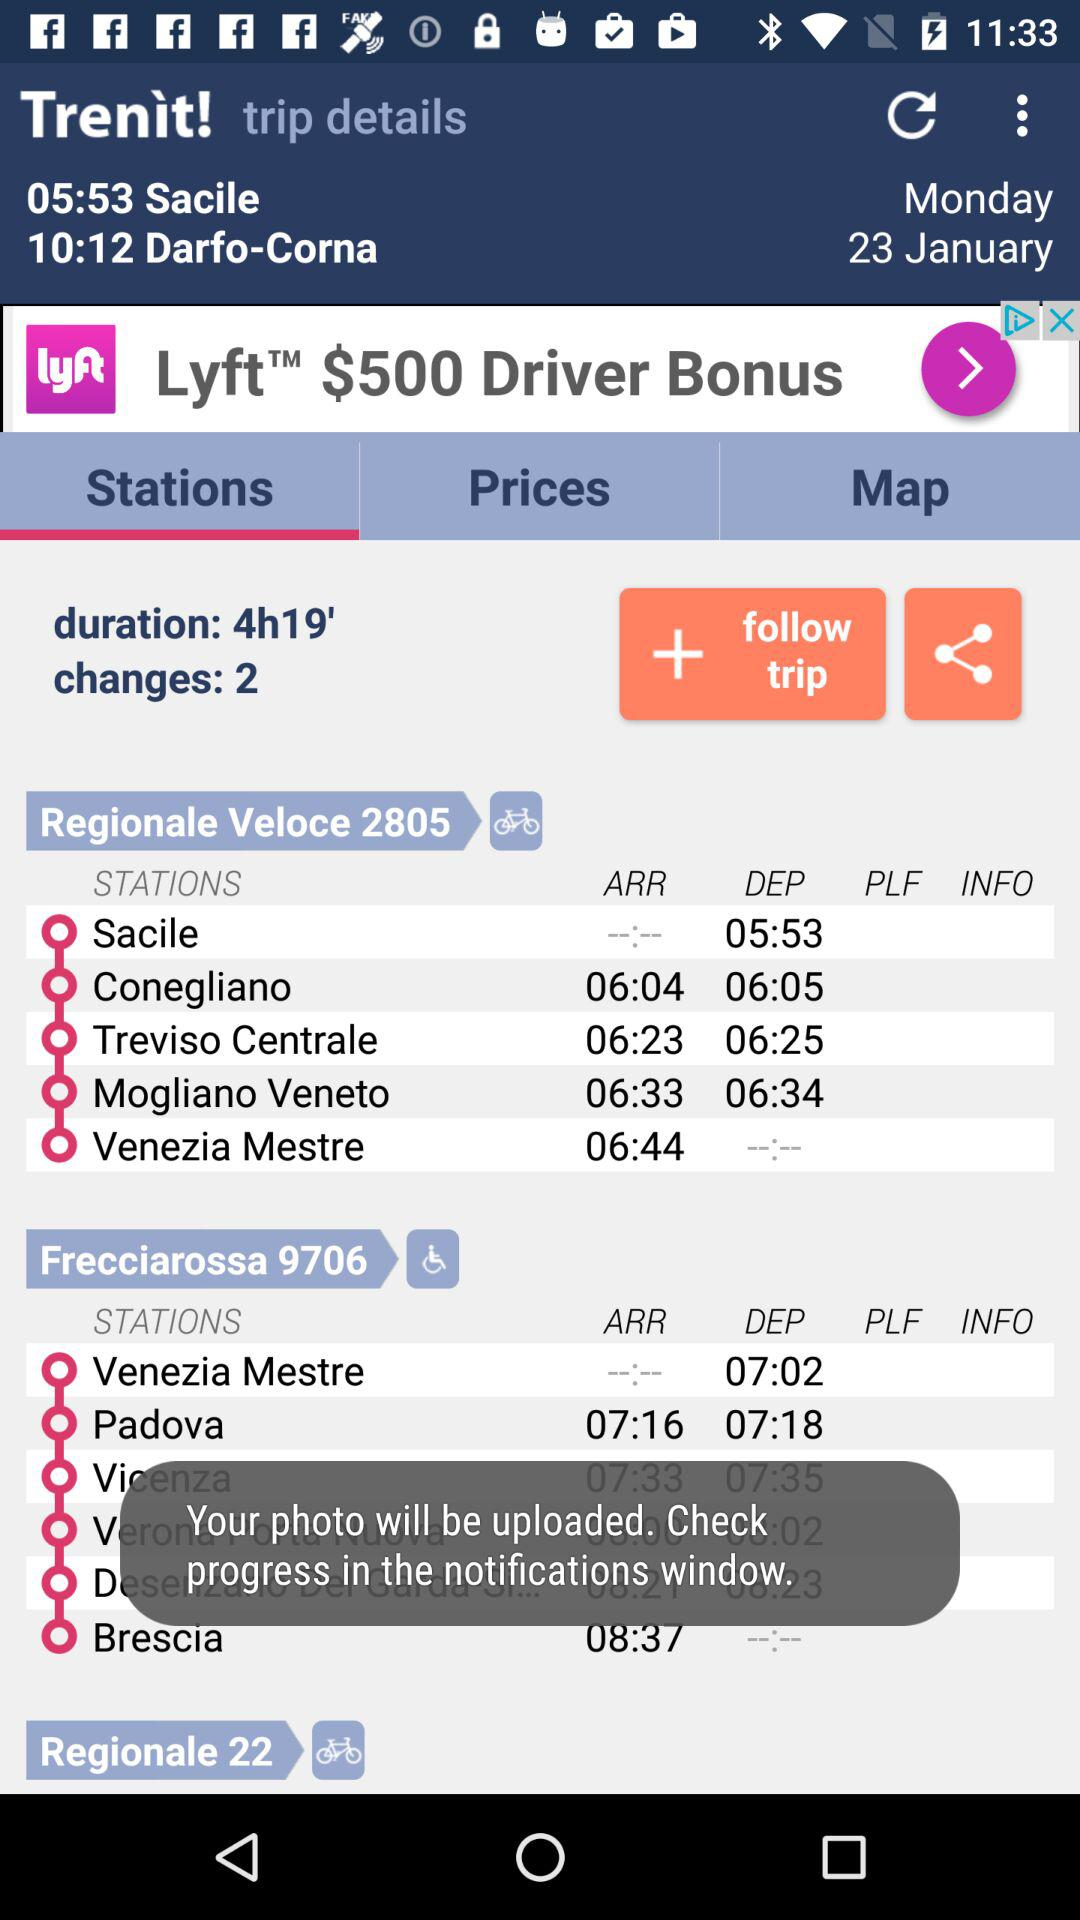What is the departure time from Sacile Station? The departure time from Sacile Station is 05:53. 